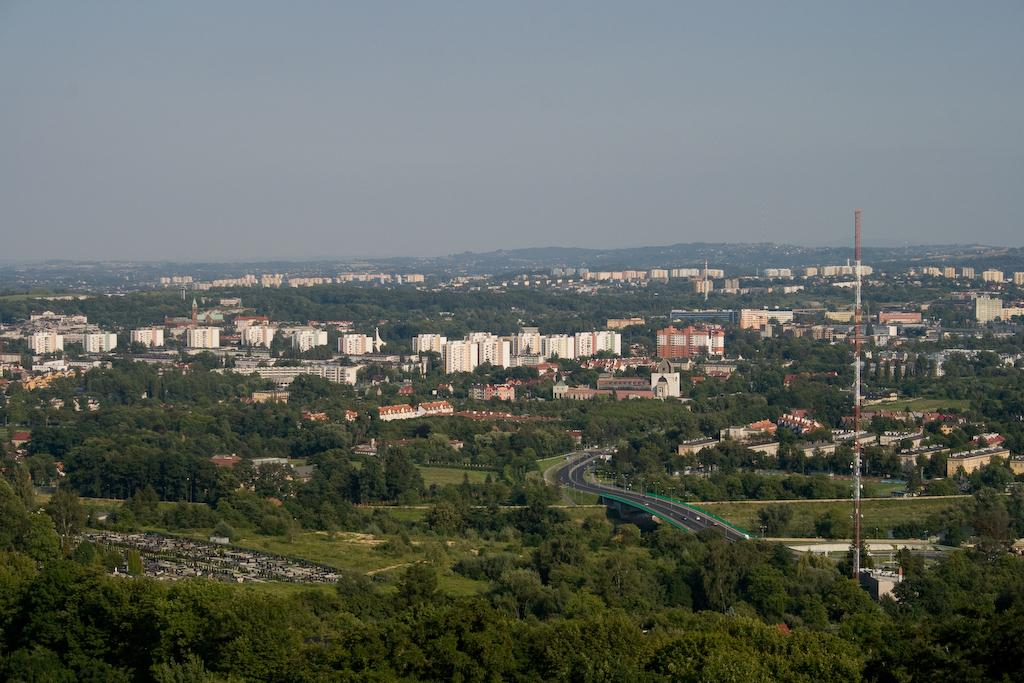What type of view is depicted in the image? The image is an aerial view. What structures can be seen in the image? There are buildings, a bridge, a tower, and poles in the image. What type of vegetation is present in the image? There are trees in the image. What type of transportation infrastructure is visible in the image? There is a road in the image. Are there any vehicles in the image? Yes, there are vehicles in the image. What is visible at the top of the image? The sky is visible at the top of the image. How does the bird join the distribution of vehicles in the image? There is no bird present in the image, so it cannot join the distribution of vehicles. 